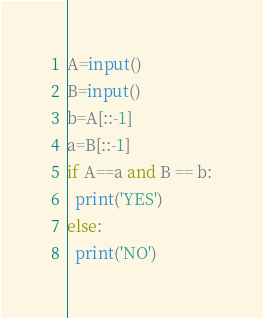<code> <loc_0><loc_0><loc_500><loc_500><_Python_>A=input()
B=input()
b=A[::-1]
a=B[::-1]
if A==a and B == b:
  print('YES')
else:
  print('NO')
</code> 